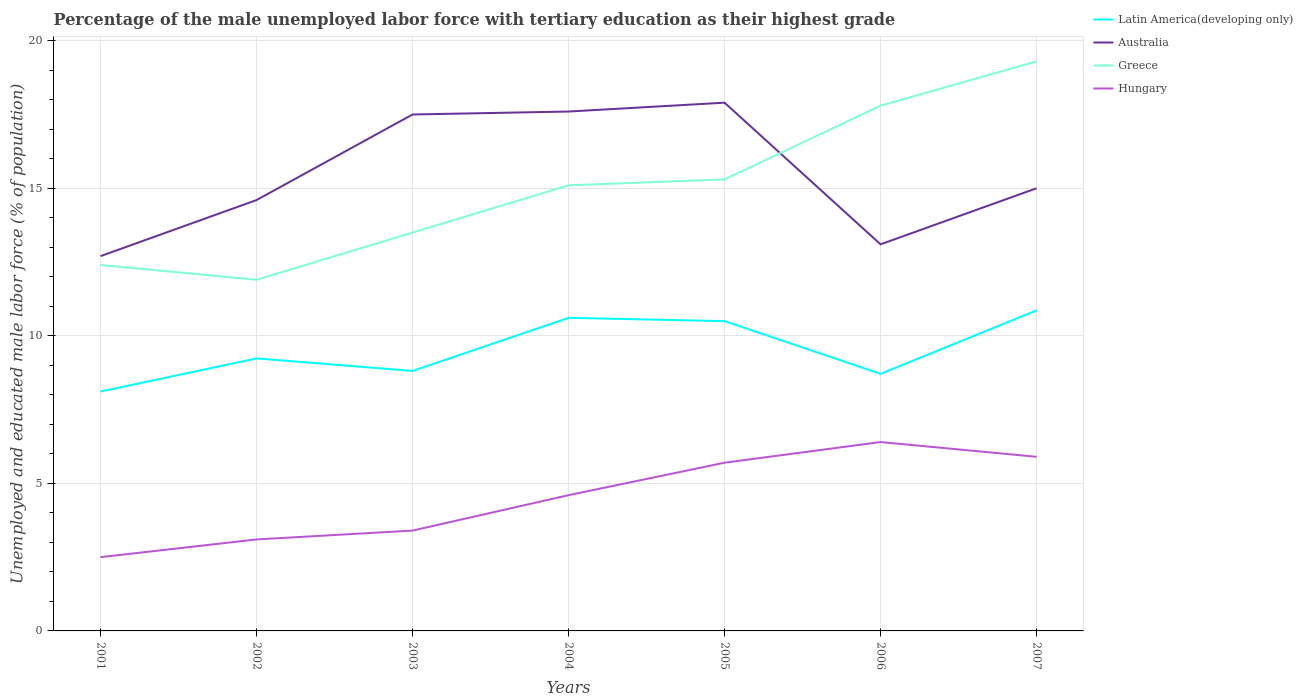How many different coloured lines are there?
Make the answer very short. 4. Does the line corresponding to Australia intersect with the line corresponding to Greece?
Your answer should be very brief. Yes. Is the number of lines equal to the number of legend labels?
Your response must be concise. Yes. Across all years, what is the maximum percentage of the unemployed male labor force with tertiary education in Latin America(developing only)?
Make the answer very short. 8.11. What is the total percentage of the unemployed male labor force with tertiary education in Hungary in the graph?
Provide a succinct answer. -1.2. What is the difference between the highest and the second highest percentage of the unemployed male labor force with tertiary education in Greece?
Keep it short and to the point. 7.4. Is the percentage of the unemployed male labor force with tertiary education in Latin America(developing only) strictly greater than the percentage of the unemployed male labor force with tertiary education in Australia over the years?
Your response must be concise. Yes. How many lines are there?
Your answer should be very brief. 4. Are the values on the major ticks of Y-axis written in scientific E-notation?
Keep it short and to the point. No. Does the graph contain any zero values?
Make the answer very short. No. Does the graph contain grids?
Provide a short and direct response. Yes. Where does the legend appear in the graph?
Your answer should be compact. Top right. What is the title of the graph?
Provide a short and direct response. Percentage of the male unemployed labor force with tertiary education as their highest grade. Does "Burundi" appear as one of the legend labels in the graph?
Make the answer very short. No. What is the label or title of the X-axis?
Provide a short and direct response. Years. What is the label or title of the Y-axis?
Provide a short and direct response. Unemployed and educated male labor force (% of population). What is the Unemployed and educated male labor force (% of population) in Latin America(developing only) in 2001?
Your answer should be compact. 8.11. What is the Unemployed and educated male labor force (% of population) of Australia in 2001?
Make the answer very short. 12.7. What is the Unemployed and educated male labor force (% of population) of Greece in 2001?
Provide a short and direct response. 12.4. What is the Unemployed and educated male labor force (% of population) of Latin America(developing only) in 2002?
Your answer should be very brief. 9.23. What is the Unemployed and educated male labor force (% of population) in Australia in 2002?
Offer a terse response. 14.6. What is the Unemployed and educated male labor force (% of population) in Greece in 2002?
Make the answer very short. 11.9. What is the Unemployed and educated male labor force (% of population) in Hungary in 2002?
Make the answer very short. 3.1. What is the Unemployed and educated male labor force (% of population) in Latin America(developing only) in 2003?
Your answer should be very brief. 8.81. What is the Unemployed and educated male labor force (% of population) in Hungary in 2003?
Provide a succinct answer. 3.4. What is the Unemployed and educated male labor force (% of population) of Latin America(developing only) in 2004?
Your answer should be compact. 10.61. What is the Unemployed and educated male labor force (% of population) of Australia in 2004?
Keep it short and to the point. 17.6. What is the Unemployed and educated male labor force (% of population) in Greece in 2004?
Ensure brevity in your answer.  15.1. What is the Unemployed and educated male labor force (% of population) in Hungary in 2004?
Ensure brevity in your answer.  4.6. What is the Unemployed and educated male labor force (% of population) of Latin America(developing only) in 2005?
Provide a short and direct response. 10.5. What is the Unemployed and educated male labor force (% of population) of Australia in 2005?
Provide a succinct answer. 17.9. What is the Unemployed and educated male labor force (% of population) of Greece in 2005?
Give a very brief answer. 15.3. What is the Unemployed and educated male labor force (% of population) in Hungary in 2005?
Your answer should be compact. 5.7. What is the Unemployed and educated male labor force (% of population) of Latin America(developing only) in 2006?
Your response must be concise. 8.71. What is the Unemployed and educated male labor force (% of population) in Australia in 2006?
Offer a terse response. 13.1. What is the Unemployed and educated male labor force (% of population) in Greece in 2006?
Your answer should be very brief. 17.8. What is the Unemployed and educated male labor force (% of population) in Hungary in 2006?
Offer a very short reply. 6.4. What is the Unemployed and educated male labor force (% of population) in Latin America(developing only) in 2007?
Give a very brief answer. 10.86. What is the Unemployed and educated male labor force (% of population) of Australia in 2007?
Ensure brevity in your answer.  15. What is the Unemployed and educated male labor force (% of population) in Greece in 2007?
Provide a short and direct response. 19.3. What is the Unemployed and educated male labor force (% of population) of Hungary in 2007?
Your response must be concise. 5.9. Across all years, what is the maximum Unemployed and educated male labor force (% of population) of Latin America(developing only)?
Your answer should be compact. 10.86. Across all years, what is the maximum Unemployed and educated male labor force (% of population) of Australia?
Make the answer very short. 17.9. Across all years, what is the maximum Unemployed and educated male labor force (% of population) of Greece?
Your response must be concise. 19.3. Across all years, what is the maximum Unemployed and educated male labor force (% of population) of Hungary?
Provide a short and direct response. 6.4. Across all years, what is the minimum Unemployed and educated male labor force (% of population) of Latin America(developing only)?
Your response must be concise. 8.11. Across all years, what is the minimum Unemployed and educated male labor force (% of population) of Australia?
Your answer should be compact. 12.7. Across all years, what is the minimum Unemployed and educated male labor force (% of population) in Greece?
Offer a very short reply. 11.9. Across all years, what is the minimum Unemployed and educated male labor force (% of population) in Hungary?
Make the answer very short. 2.5. What is the total Unemployed and educated male labor force (% of population) in Latin America(developing only) in the graph?
Provide a short and direct response. 66.84. What is the total Unemployed and educated male labor force (% of population) of Australia in the graph?
Provide a short and direct response. 108.4. What is the total Unemployed and educated male labor force (% of population) of Greece in the graph?
Give a very brief answer. 105.3. What is the total Unemployed and educated male labor force (% of population) of Hungary in the graph?
Provide a succinct answer. 31.6. What is the difference between the Unemployed and educated male labor force (% of population) of Latin America(developing only) in 2001 and that in 2002?
Provide a short and direct response. -1.12. What is the difference between the Unemployed and educated male labor force (% of population) in Australia in 2001 and that in 2002?
Offer a terse response. -1.9. What is the difference between the Unemployed and educated male labor force (% of population) of Greece in 2001 and that in 2002?
Your response must be concise. 0.5. What is the difference between the Unemployed and educated male labor force (% of population) in Latin America(developing only) in 2001 and that in 2003?
Give a very brief answer. -0.7. What is the difference between the Unemployed and educated male labor force (% of population) in Australia in 2001 and that in 2003?
Your response must be concise. -4.8. What is the difference between the Unemployed and educated male labor force (% of population) in Hungary in 2001 and that in 2003?
Provide a succinct answer. -0.9. What is the difference between the Unemployed and educated male labor force (% of population) in Latin America(developing only) in 2001 and that in 2004?
Give a very brief answer. -2.5. What is the difference between the Unemployed and educated male labor force (% of population) in Australia in 2001 and that in 2004?
Offer a very short reply. -4.9. What is the difference between the Unemployed and educated male labor force (% of population) of Hungary in 2001 and that in 2004?
Keep it short and to the point. -2.1. What is the difference between the Unemployed and educated male labor force (% of population) of Latin America(developing only) in 2001 and that in 2005?
Your answer should be very brief. -2.38. What is the difference between the Unemployed and educated male labor force (% of population) of Australia in 2001 and that in 2005?
Provide a short and direct response. -5.2. What is the difference between the Unemployed and educated male labor force (% of population) in Greece in 2001 and that in 2005?
Ensure brevity in your answer.  -2.9. What is the difference between the Unemployed and educated male labor force (% of population) of Hungary in 2001 and that in 2005?
Ensure brevity in your answer.  -3.2. What is the difference between the Unemployed and educated male labor force (% of population) of Latin America(developing only) in 2001 and that in 2006?
Provide a succinct answer. -0.6. What is the difference between the Unemployed and educated male labor force (% of population) in Latin America(developing only) in 2001 and that in 2007?
Your answer should be compact. -2.75. What is the difference between the Unemployed and educated male labor force (% of population) of Greece in 2001 and that in 2007?
Offer a very short reply. -6.9. What is the difference between the Unemployed and educated male labor force (% of population) of Latin America(developing only) in 2002 and that in 2003?
Offer a terse response. 0.43. What is the difference between the Unemployed and educated male labor force (% of population) of Greece in 2002 and that in 2003?
Your response must be concise. -1.6. What is the difference between the Unemployed and educated male labor force (% of population) in Hungary in 2002 and that in 2003?
Keep it short and to the point. -0.3. What is the difference between the Unemployed and educated male labor force (% of population) in Latin America(developing only) in 2002 and that in 2004?
Provide a short and direct response. -1.37. What is the difference between the Unemployed and educated male labor force (% of population) of Latin America(developing only) in 2002 and that in 2005?
Ensure brevity in your answer.  -1.26. What is the difference between the Unemployed and educated male labor force (% of population) of Australia in 2002 and that in 2005?
Give a very brief answer. -3.3. What is the difference between the Unemployed and educated male labor force (% of population) in Latin America(developing only) in 2002 and that in 2006?
Your answer should be compact. 0.52. What is the difference between the Unemployed and educated male labor force (% of population) in Latin America(developing only) in 2002 and that in 2007?
Make the answer very short. -1.63. What is the difference between the Unemployed and educated male labor force (% of population) of Greece in 2002 and that in 2007?
Your response must be concise. -7.4. What is the difference between the Unemployed and educated male labor force (% of population) of Hungary in 2002 and that in 2007?
Make the answer very short. -2.8. What is the difference between the Unemployed and educated male labor force (% of population) in Latin America(developing only) in 2003 and that in 2004?
Your response must be concise. -1.8. What is the difference between the Unemployed and educated male labor force (% of population) of Australia in 2003 and that in 2004?
Ensure brevity in your answer.  -0.1. What is the difference between the Unemployed and educated male labor force (% of population) in Greece in 2003 and that in 2004?
Keep it short and to the point. -1.6. What is the difference between the Unemployed and educated male labor force (% of population) in Hungary in 2003 and that in 2004?
Your answer should be compact. -1.2. What is the difference between the Unemployed and educated male labor force (% of population) in Latin America(developing only) in 2003 and that in 2005?
Ensure brevity in your answer.  -1.69. What is the difference between the Unemployed and educated male labor force (% of population) of Greece in 2003 and that in 2005?
Your answer should be compact. -1.8. What is the difference between the Unemployed and educated male labor force (% of population) in Hungary in 2003 and that in 2005?
Give a very brief answer. -2.3. What is the difference between the Unemployed and educated male labor force (% of population) in Latin America(developing only) in 2003 and that in 2006?
Your answer should be compact. 0.1. What is the difference between the Unemployed and educated male labor force (% of population) of Greece in 2003 and that in 2006?
Your answer should be compact. -4.3. What is the difference between the Unemployed and educated male labor force (% of population) of Latin America(developing only) in 2003 and that in 2007?
Provide a short and direct response. -2.05. What is the difference between the Unemployed and educated male labor force (% of population) in Australia in 2003 and that in 2007?
Make the answer very short. 2.5. What is the difference between the Unemployed and educated male labor force (% of population) of Greece in 2003 and that in 2007?
Your response must be concise. -5.8. What is the difference between the Unemployed and educated male labor force (% of population) of Hungary in 2003 and that in 2007?
Give a very brief answer. -2.5. What is the difference between the Unemployed and educated male labor force (% of population) in Latin America(developing only) in 2004 and that in 2005?
Your response must be concise. 0.11. What is the difference between the Unemployed and educated male labor force (% of population) of Australia in 2004 and that in 2005?
Your answer should be compact. -0.3. What is the difference between the Unemployed and educated male labor force (% of population) in Hungary in 2004 and that in 2005?
Provide a short and direct response. -1.1. What is the difference between the Unemployed and educated male labor force (% of population) in Latin America(developing only) in 2004 and that in 2006?
Provide a short and direct response. 1.9. What is the difference between the Unemployed and educated male labor force (% of population) in Australia in 2004 and that in 2006?
Your answer should be compact. 4.5. What is the difference between the Unemployed and educated male labor force (% of population) of Latin America(developing only) in 2004 and that in 2007?
Your response must be concise. -0.25. What is the difference between the Unemployed and educated male labor force (% of population) in Australia in 2004 and that in 2007?
Give a very brief answer. 2.6. What is the difference between the Unemployed and educated male labor force (% of population) in Greece in 2004 and that in 2007?
Your answer should be compact. -4.2. What is the difference between the Unemployed and educated male labor force (% of population) of Hungary in 2004 and that in 2007?
Offer a very short reply. -1.3. What is the difference between the Unemployed and educated male labor force (% of population) in Latin America(developing only) in 2005 and that in 2006?
Make the answer very short. 1.79. What is the difference between the Unemployed and educated male labor force (% of population) in Greece in 2005 and that in 2006?
Provide a short and direct response. -2.5. What is the difference between the Unemployed and educated male labor force (% of population) of Hungary in 2005 and that in 2006?
Ensure brevity in your answer.  -0.7. What is the difference between the Unemployed and educated male labor force (% of population) in Latin America(developing only) in 2005 and that in 2007?
Provide a succinct answer. -0.37. What is the difference between the Unemployed and educated male labor force (% of population) of Latin America(developing only) in 2006 and that in 2007?
Provide a succinct answer. -2.15. What is the difference between the Unemployed and educated male labor force (% of population) in Greece in 2006 and that in 2007?
Keep it short and to the point. -1.5. What is the difference between the Unemployed and educated male labor force (% of population) in Latin America(developing only) in 2001 and the Unemployed and educated male labor force (% of population) in Australia in 2002?
Offer a very short reply. -6.49. What is the difference between the Unemployed and educated male labor force (% of population) in Latin America(developing only) in 2001 and the Unemployed and educated male labor force (% of population) in Greece in 2002?
Keep it short and to the point. -3.79. What is the difference between the Unemployed and educated male labor force (% of population) in Latin America(developing only) in 2001 and the Unemployed and educated male labor force (% of population) in Hungary in 2002?
Provide a succinct answer. 5.01. What is the difference between the Unemployed and educated male labor force (% of population) of Australia in 2001 and the Unemployed and educated male labor force (% of population) of Greece in 2002?
Offer a terse response. 0.8. What is the difference between the Unemployed and educated male labor force (% of population) of Australia in 2001 and the Unemployed and educated male labor force (% of population) of Hungary in 2002?
Provide a short and direct response. 9.6. What is the difference between the Unemployed and educated male labor force (% of population) in Greece in 2001 and the Unemployed and educated male labor force (% of population) in Hungary in 2002?
Keep it short and to the point. 9.3. What is the difference between the Unemployed and educated male labor force (% of population) of Latin America(developing only) in 2001 and the Unemployed and educated male labor force (% of population) of Australia in 2003?
Ensure brevity in your answer.  -9.39. What is the difference between the Unemployed and educated male labor force (% of population) of Latin America(developing only) in 2001 and the Unemployed and educated male labor force (% of population) of Greece in 2003?
Offer a terse response. -5.39. What is the difference between the Unemployed and educated male labor force (% of population) in Latin America(developing only) in 2001 and the Unemployed and educated male labor force (% of population) in Hungary in 2003?
Ensure brevity in your answer.  4.71. What is the difference between the Unemployed and educated male labor force (% of population) in Greece in 2001 and the Unemployed and educated male labor force (% of population) in Hungary in 2003?
Offer a terse response. 9. What is the difference between the Unemployed and educated male labor force (% of population) of Latin America(developing only) in 2001 and the Unemployed and educated male labor force (% of population) of Australia in 2004?
Provide a short and direct response. -9.49. What is the difference between the Unemployed and educated male labor force (% of population) of Latin America(developing only) in 2001 and the Unemployed and educated male labor force (% of population) of Greece in 2004?
Provide a succinct answer. -6.99. What is the difference between the Unemployed and educated male labor force (% of population) of Latin America(developing only) in 2001 and the Unemployed and educated male labor force (% of population) of Hungary in 2004?
Offer a terse response. 3.51. What is the difference between the Unemployed and educated male labor force (% of population) in Australia in 2001 and the Unemployed and educated male labor force (% of population) in Greece in 2004?
Your response must be concise. -2.4. What is the difference between the Unemployed and educated male labor force (% of population) of Greece in 2001 and the Unemployed and educated male labor force (% of population) of Hungary in 2004?
Keep it short and to the point. 7.8. What is the difference between the Unemployed and educated male labor force (% of population) in Latin America(developing only) in 2001 and the Unemployed and educated male labor force (% of population) in Australia in 2005?
Provide a short and direct response. -9.79. What is the difference between the Unemployed and educated male labor force (% of population) of Latin America(developing only) in 2001 and the Unemployed and educated male labor force (% of population) of Greece in 2005?
Your answer should be compact. -7.19. What is the difference between the Unemployed and educated male labor force (% of population) in Latin America(developing only) in 2001 and the Unemployed and educated male labor force (% of population) in Hungary in 2005?
Offer a very short reply. 2.41. What is the difference between the Unemployed and educated male labor force (% of population) of Australia in 2001 and the Unemployed and educated male labor force (% of population) of Greece in 2005?
Make the answer very short. -2.6. What is the difference between the Unemployed and educated male labor force (% of population) of Greece in 2001 and the Unemployed and educated male labor force (% of population) of Hungary in 2005?
Ensure brevity in your answer.  6.7. What is the difference between the Unemployed and educated male labor force (% of population) in Latin America(developing only) in 2001 and the Unemployed and educated male labor force (% of population) in Australia in 2006?
Provide a succinct answer. -4.99. What is the difference between the Unemployed and educated male labor force (% of population) of Latin America(developing only) in 2001 and the Unemployed and educated male labor force (% of population) of Greece in 2006?
Provide a short and direct response. -9.69. What is the difference between the Unemployed and educated male labor force (% of population) of Latin America(developing only) in 2001 and the Unemployed and educated male labor force (% of population) of Hungary in 2006?
Provide a succinct answer. 1.71. What is the difference between the Unemployed and educated male labor force (% of population) in Australia in 2001 and the Unemployed and educated male labor force (% of population) in Greece in 2006?
Your answer should be very brief. -5.1. What is the difference between the Unemployed and educated male labor force (% of population) in Latin America(developing only) in 2001 and the Unemployed and educated male labor force (% of population) in Australia in 2007?
Provide a succinct answer. -6.89. What is the difference between the Unemployed and educated male labor force (% of population) in Latin America(developing only) in 2001 and the Unemployed and educated male labor force (% of population) in Greece in 2007?
Keep it short and to the point. -11.19. What is the difference between the Unemployed and educated male labor force (% of population) of Latin America(developing only) in 2001 and the Unemployed and educated male labor force (% of population) of Hungary in 2007?
Offer a very short reply. 2.21. What is the difference between the Unemployed and educated male labor force (% of population) in Australia in 2001 and the Unemployed and educated male labor force (% of population) in Hungary in 2007?
Give a very brief answer. 6.8. What is the difference between the Unemployed and educated male labor force (% of population) in Greece in 2001 and the Unemployed and educated male labor force (% of population) in Hungary in 2007?
Your answer should be very brief. 6.5. What is the difference between the Unemployed and educated male labor force (% of population) of Latin America(developing only) in 2002 and the Unemployed and educated male labor force (% of population) of Australia in 2003?
Provide a succinct answer. -8.27. What is the difference between the Unemployed and educated male labor force (% of population) in Latin America(developing only) in 2002 and the Unemployed and educated male labor force (% of population) in Greece in 2003?
Keep it short and to the point. -4.27. What is the difference between the Unemployed and educated male labor force (% of population) in Latin America(developing only) in 2002 and the Unemployed and educated male labor force (% of population) in Hungary in 2003?
Your answer should be very brief. 5.83. What is the difference between the Unemployed and educated male labor force (% of population) in Australia in 2002 and the Unemployed and educated male labor force (% of population) in Greece in 2003?
Keep it short and to the point. 1.1. What is the difference between the Unemployed and educated male labor force (% of population) in Australia in 2002 and the Unemployed and educated male labor force (% of population) in Hungary in 2003?
Make the answer very short. 11.2. What is the difference between the Unemployed and educated male labor force (% of population) in Latin America(developing only) in 2002 and the Unemployed and educated male labor force (% of population) in Australia in 2004?
Make the answer very short. -8.37. What is the difference between the Unemployed and educated male labor force (% of population) of Latin America(developing only) in 2002 and the Unemployed and educated male labor force (% of population) of Greece in 2004?
Offer a terse response. -5.87. What is the difference between the Unemployed and educated male labor force (% of population) in Latin America(developing only) in 2002 and the Unemployed and educated male labor force (% of population) in Hungary in 2004?
Offer a very short reply. 4.63. What is the difference between the Unemployed and educated male labor force (% of population) in Australia in 2002 and the Unemployed and educated male labor force (% of population) in Greece in 2004?
Offer a very short reply. -0.5. What is the difference between the Unemployed and educated male labor force (% of population) of Australia in 2002 and the Unemployed and educated male labor force (% of population) of Hungary in 2004?
Make the answer very short. 10. What is the difference between the Unemployed and educated male labor force (% of population) of Greece in 2002 and the Unemployed and educated male labor force (% of population) of Hungary in 2004?
Make the answer very short. 7.3. What is the difference between the Unemployed and educated male labor force (% of population) of Latin America(developing only) in 2002 and the Unemployed and educated male labor force (% of population) of Australia in 2005?
Ensure brevity in your answer.  -8.67. What is the difference between the Unemployed and educated male labor force (% of population) in Latin America(developing only) in 2002 and the Unemployed and educated male labor force (% of population) in Greece in 2005?
Offer a very short reply. -6.07. What is the difference between the Unemployed and educated male labor force (% of population) in Latin America(developing only) in 2002 and the Unemployed and educated male labor force (% of population) in Hungary in 2005?
Keep it short and to the point. 3.53. What is the difference between the Unemployed and educated male labor force (% of population) in Latin America(developing only) in 2002 and the Unemployed and educated male labor force (% of population) in Australia in 2006?
Your answer should be compact. -3.87. What is the difference between the Unemployed and educated male labor force (% of population) in Latin America(developing only) in 2002 and the Unemployed and educated male labor force (% of population) in Greece in 2006?
Keep it short and to the point. -8.57. What is the difference between the Unemployed and educated male labor force (% of population) in Latin America(developing only) in 2002 and the Unemployed and educated male labor force (% of population) in Hungary in 2006?
Ensure brevity in your answer.  2.83. What is the difference between the Unemployed and educated male labor force (% of population) of Greece in 2002 and the Unemployed and educated male labor force (% of population) of Hungary in 2006?
Keep it short and to the point. 5.5. What is the difference between the Unemployed and educated male labor force (% of population) in Latin America(developing only) in 2002 and the Unemployed and educated male labor force (% of population) in Australia in 2007?
Provide a succinct answer. -5.77. What is the difference between the Unemployed and educated male labor force (% of population) of Latin America(developing only) in 2002 and the Unemployed and educated male labor force (% of population) of Greece in 2007?
Make the answer very short. -10.07. What is the difference between the Unemployed and educated male labor force (% of population) of Latin America(developing only) in 2002 and the Unemployed and educated male labor force (% of population) of Hungary in 2007?
Give a very brief answer. 3.33. What is the difference between the Unemployed and educated male labor force (% of population) of Australia in 2002 and the Unemployed and educated male labor force (% of population) of Greece in 2007?
Make the answer very short. -4.7. What is the difference between the Unemployed and educated male labor force (% of population) of Australia in 2002 and the Unemployed and educated male labor force (% of population) of Hungary in 2007?
Provide a short and direct response. 8.7. What is the difference between the Unemployed and educated male labor force (% of population) of Latin America(developing only) in 2003 and the Unemployed and educated male labor force (% of population) of Australia in 2004?
Keep it short and to the point. -8.79. What is the difference between the Unemployed and educated male labor force (% of population) in Latin America(developing only) in 2003 and the Unemployed and educated male labor force (% of population) in Greece in 2004?
Ensure brevity in your answer.  -6.29. What is the difference between the Unemployed and educated male labor force (% of population) in Latin America(developing only) in 2003 and the Unemployed and educated male labor force (% of population) in Hungary in 2004?
Give a very brief answer. 4.21. What is the difference between the Unemployed and educated male labor force (% of population) of Australia in 2003 and the Unemployed and educated male labor force (% of population) of Greece in 2004?
Your answer should be compact. 2.4. What is the difference between the Unemployed and educated male labor force (% of population) in Greece in 2003 and the Unemployed and educated male labor force (% of population) in Hungary in 2004?
Give a very brief answer. 8.9. What is the difference between the Unemployed and educated male labor force (% of population) of Latin America(developing only) in 2003 and the Unemployed and educated male labor force (% of population) of Australia in 2005?
Give a very brief answer. -9.09. What is the difference between the Unemployed and educated male labor force (% of population) of Latin America(developing only) in 2003 and the Unemployed and educated male labor force (% of population) of Greece in 2005?
Ensure brevity in your answer.  -6.49. What is the difference between the Unemployed and educated male labor force (% of population) in Latin America(developing only) in 2003 and the Unemployed and educated male labor force (% of population) in Hungary in 2005?
Provide a succinct answer. 3.11. What is the difference between the Unemployed and educated male labor force (% of population) of Australia in 2003 and the Unemployed and educated male labor force (% of population) of Greece in 2005?
Provide a succinct answer. 2.2. What is the difference between the Unemployed and educated male labor force (% of population) of Australia in 2003 and the Unemployed and educated male labor force (% of population) of Hungary in 2005?
Your answer should be very brief. 11.8. What is the difference between the Unemployed and educated male labor force (% of population) in Greece in 2003 and the Unemployed and educated male labor force (% of population) in Hungary in 2005?
Provide a succinct answer. 7.8. What is the difference between the Unemployed and educated male labor force (% of population) in Latin America(developing only) in 2003 and the Unemployed and educated male labor force (% of population) in Australia in 2006?
Provide a short and direct response. -4.29. What is the difference between the Unemployed and educated male labor force (% of population) of Latin America(developing only) in 2003 and the Unemployed and educated male labor force (% of population) of Greece in 2006?
Give a very brief answer. -8.99. What is the difference between the Unemployed and educated male labor force (% of population) of Latin America(developing only) in 2003 and the Unemployed and educated male labor force (% of population) of Hungary in 2006?
Your answer should be very brief. 2.41. What is the difference between the Unemployed and educated male labor force (% of population) of Australia in 2003 and the Unemployed and educated male labor force (% of population) of Hungary in 2006?
Your answer should be compact. 11.1. What is the difference between the Unemployed and educated male labor force (% of population) in Greece in 2003 and the Unemployed and educated male labor force (% of population) in Hungary in 2006?
Ensure brevity in your answer.  7.1. What is the difference between the Unemployed and educated male labor force (% of population) of Latin America(developing only) in 2003 and the Unemployed and educated male labor force (% of population) of Australia in 2007?
Offer a terse response. -6.19. What is the difference between the Unemployed and educated male labor force (% of population) of Latin America(developing only) in 2003 and the Unemployed and educated male labor force (% of population) of Greece in 2007?
Your response must be concise. -10.49. What is the difference between the Unemployed and educated male labor force (% of population) in Latin America(developing only) in 2003 and the Unemployed and educated male labor force (% of population) in Hungary in 2007?
Your answer should be compact. 2.91. What is the difference between the Unemployed and educated male labor force (% of population) of Australia in 2003 and the Unemployed and educated male labor force (% of population) of Greece in 2007?
Give a very brief answer. -1.8. What is the difference between the Unemployed and educated male labor force (% of population) of Australia in 2003 and the Unemployed and educated male labor force (% of population) of Hungary in 2007?
Offer a terse response. 11.6. What is the difference between the Unemployed and educated male labor force (% of population) in Latin America(developing only) in 2004 and the Unemployed and educated male labor force (% of population) in Australia in 2005?
Provide a short and direct response. -7.29. What is the difference between the Unemployed and educated male labor force (% of population) of Latin America(developing only) in 2004 and the Unemployed and educated male labor force (% of population) of Greece in 2005?
Your answer should be very brief. -4.69. What is the difference between the Unemployed and educated male labor force (% of population) of Latin America(developing only) in 2004 and the Unemployed and educated male labor force (% of population) of Hungary in 2005?
Make the answer very short. 4.91. What is the difference between the Unemployed and educated male labor force (% of population) in Latin America(developing only) in 2004 and the Unemployed and educated male labor force (% of population) in Australia in 2006?
Provide a short and direct response. -2.49. What is the difference between the Unemployed and educated male labor force (% of population) in Latin America(developing only) in 2004 and the Unemployed and educated male labor force (% of population) in Greece in 2006?
Ensure brevity in your answer.  -7.19. What is the difference between the Unemployed and educated male labor force (% of population) in Latin America(developing only) in 2004 and the Unemployed and educated male labor force (% of population) in Hungary in 2006?
Your response must be concise. 4.21. What is the difference between the Unemployed and educated male labor force (% of population) of Australia in 2004 and the Unemployed and educated male labor force (% of population) of Greece in 2006?
Offer a terse response. -0.2. What is the difference between the Unemployed and educated male labor force (% of population) in Greece in 2004 and the Unemployed and educated male labor force (% of population) in Hungary in 2006?
Provide a succinct answer. 8.7. What is the difference between the Unemployed and educated male labor force (% of population) in Latin America(developing only) in 2004 and the Unemployed and educated male labor force (% of population) in Australia in 2007?
Ensure brevity in your answer.  -4.39. What is the difference between the Unemployed and educated male labor force (% of population) of Latin America(developing only) in 2004 and the Unemployed and educated male labor force (% of population) of Greece in 2007?
Provide a succinct answer. -8.69. What is the difference between the Unemployed and educated male labor force (% of population) in Latin America(developing only) in 2004 and the Unemployed and educated male labor force (% of population) in Hungary in 2007?
Provide a short and direct response. 4.71. What is the difference between the Unemployed and educated male labor force (% of population) in Australia in 2004 and the Unemployed and educated male labor force (% of population) in Greece in 2007?
Ensure brevity in your answer.  -1.7. What is the difference between the Unemployed and educated male labor force (% of population) in Australia in 2004 and the Unemployed and educated male labor force (% of population) in Hungary in 2007?
Provide a succinct answer. 11.7. What is the difference between the Unemployed and educated male labor force (% of population) of Latin America(developing only) in 2005 and the Unemployed and educated male labor force (% of population) of Australia in 2006?
Give a very brief answer. -2.6. What is the difference between the Unemployed and educated male labor force (% of population) in Latin America(developing only) in 2005 and the Unemployed and educated male labor force (% of population) in Greece in 2006?
Offer a very short reply. -7.3. What is the difference between the Unemployed and educated male labor force (% of population) in Latin America(developing only) in 2005 and the Unemployed and educated male labor force (% of population) in Hungary in 2006?
Offer a very short reply. 4.1. What is the difference between the Unemployed and educated male labor force (% of population) in Australia in 2005 and the Unemployed and educated male labor force (% of population) in Greece in 2006?
Provide a short and direct response. 0.1. What is the difference between the Unemployed and educated male labor force (% of population) of Australia in 2005 and the Unemployed and educated male labor force (% of population) of Hungary in 2006?
Provide a succinct answer. 11.5. What is the difference between the Unemployed and educated male labor force (% of population) of Greece in 2005 and the Unemployed and educated male labor force (% of population) of Hungary in 2006?
Make the answer very short. 8.9. What is the difference between the Unemployed and educated male labor force (% of population) of Latin America(developing only) in 2005 and the Unemployed and educated male labor force (% of population) of Australia in 2007?
Offer a very short reply. -4.5. What is the difference between the Unemployed and educated male labor force (% of population) in Latin America(developing only) in 2005 and the Unemployed and educated male labor force (% of population) in Greece in 2007?
Keep it short and to the point. -8.8. What is the difference between the Unemployed and educated male labor force (% of population) of Latin America(developing only) in 2005 and the Unemployed and educated male labor force (% of population) of Hungary in 2007?
Keep it short and to the point. 4.6. What is the difference between the Unemployed and educated male labor force (% of population) in Australia in 2005 and the Unemployed and educated male labor force (% of population) in Greece in 2007?
Your response must be concise. -1.4. What is the difference between the Unemployed and educated male labor force (% of population) in Australia in 2005 and the Unemployed and educated male labor force (% of population) in Hungary in 2007?
Provide a succinct answer. 12. What is the difference between the Unemployed and educated male labor force (% of population) in Latin America(developing only) in 2006 and the Unemployed and educated male labor force (% of population) in Australia in 2007?
Keep it short and to the point. -6.29. What is the difference between the Unemployed and educated male labor force (% of population) of Latin America(developing only) in 2006 and the Unemployed and educated male labor force (% of population) of Greece in 2007?
Offer a very short reply. -10.59. What is the difference between the Unemployed and educated male labor force (% of population) of Latin America(developing only) in 2006 and the Unemployed and educated male labor force (% of population) of Hungary in 2007?
Your answer should be compact. 2.81. What is the difference between the Unemployed and educated male labor force (% of population) of Australia in 2006 and the Unemployed and educated male labor force (% of population) of Greece in 2007?
Give a very brief answer. -6.2. What is the difference between the Unemployed and educated male labor force (% of population) in Greece in 2006 and the Unemployed and educated male labor force (% of population) in Hungary in 2007?
Keep it short and to the point. 11.9. What is the average Unemployed and educated male labor force (% of population) in Latin America(developing only) per year?
Offer a very short reply. 9.55. What is the average Unemployed and educated male labor force (% of population) of Australia per year?
Your answer should be very brief. 15.49. What is the average Unemployed and educated male labor force (% of population) of Greece per year?
Your response must be concise. 15.04. What is the average Unemployed and educated male labor force (% of population) in Hungary per year?
Make the answer very short. 4.51. In the year 2001, what is the difference between the Unemployed and educated male labor force (% of population) of Latin America(developing only) and Unemployed and educated male labor force (% of population) of Australia?
Provide a succinct answer. -4.59. In the year 2001, what is the difference between the Unemployed and educated male labor force (% of population) in Latin America(developing only) and Unemployed and educated male labor force (% of population) in Greece?
Ensure brevity in your answer.  -4.29. In the year 2001, what is the difference between the Unemployed and educated male labor force (% of population) in Latin America(developing only) and Unemployed and educated male labor force (% of population) in Hungary?
Offer a terse response. 5.61. In the year 2001, what is the difference between the Unemployed and educated male labor force (% of population) in Australia and Unemployed and educated male labor force (% of population) in Greece?
Provide a succinct answer. 0.3. In the year 2002, what is the difference between the Unemployed and educated male labor force (% of population) in Latin America(developing only) and Unemployed and educated male labor force (% of population) in Australia?
Offer a terse response. -5.37. In the year 2002, what is the difference between the Unemployed and educated male labor force (% of population) of Latin America(developing only) and Unemployed and educated male labor force (% of population) of Greece?
Keep it short and to the point. -2.67. In the year 2002, what is the difference between the Unemployed and educated male labor force (% of population) of Latin America(developing only) and Unemployed and educated male labor force (% of population) of Hungary?
Provide a short and direct response. 6.13. In the year 2002, what is the difference between the Unemployed and educated male labor force (% of population) of Australia and Unemployed and educated male labor force (% of population) of Hungary?
Give a very brief answer. 11.5. In the year 2002, what is the difference between the Unemployed and educated male labor force (% of population) of Greece and Unemployed and educated male labor force (% of population) of Hungary?
Keep it short and to the point. 8.8. In the year 2003, what is the difference between the Unemployed and educated male labor force (% of population) in Latin America(developing only) and Unemployed and educated male labor force (% of population) in Australia?
Your answer should be very brief. -8.69. In the year 2003, what is the difference between the Unemployed and educated male labor force (% of population) in Latin America(developing only) and Unemployed and educated male labor force (% of population) in Greece?
Provide a succinct answer. -4.69. In the year 2003, what is the difference between the Unemployed and educated male labor force (% of population) in Latin America(developing only) and Unemployed and educated male labor force (% of population) in Hungary?
Give a very brief answer. 5.41. In the year 2004, what is the difference between the Unemployed and educated male labor force (% of population) of Latin America(developing only) and Unemployed and educated male labor force (% of population) of Australia?
Offer a very short reply. -6.99. In the year 2004, what is the difference between the Unemployed and educated male labor force (% of population) in Latin America(developing only) and Unemployed and educated male labor force (% of population) in Greece?
Offer a very short reply. -4.49. In the year 2004, what is the difference between the Unemployed and educated male labor force (% of population) in Latin America(developing only) and Unemployed and educated male labor force (% of population) in Hungary?
Provide a short and direct response. 6.01. In the year 2004, what is the difference between the Unemployed and educated male labor force (% of population) in Greece and Unemployed and educated male labor force (% of population) in Hungary?
Keep it short and to the point. 10.5. In the year 2005, what is the difference between the Unemployed and educated male labor force (% of population) in Latin America(developing only) and Unemployed and educated male labor force (% of population) in Australia?
Give a very brief answer. -7.4. In the year 2005, what is the difference between the Unemployed and educated male labor force (% of population) of Latin America(developing only) and Unemployed and educated male labor force (% of population) of Greece?
Provide a short and direct response. -4.8. In the year 2005, what is the difference between the Unemployed and educated male labor force (% of population) in Latin America(developing only) and Unemployed and educated male labor force (% of population) in Hungary?
Your answer should be very brief. 4.8. In the year 2005, what is the difference between the Unemployed and educated male labor force (% of population) of Australia and Unemployed and educated male labor force (% of population) of Greece?
Provide a short and direct response. 2.6. In the year 2005, what is the difference between the Unemployed and educated male labor force (% of population) in Greece and Unemployed and educated male labor force (% of population) in Hungary?
Your answer should be very brief. 9.6. In the year 2006, what is the difference between the Unemployed and educated male labor force (% of population) in Latin America(developing only) and Unemployed and educated male labor force (% of population) in Australia?
Offer a very short reply. -4.39. In the year 2006, what is the difference between the Unemployed and educated male labor force (% of population) in Latin America(developing only) and Unemployed and educated male labor force (% of population) in Greece?
Keep it short and to the point. -9.09. In the year 2006, what is the difference between the Unemployed and educated male labor force (% of population) in Latin America(developing only) and Unemployed and educated male labor force (% of population) in Hungary?
Provide a succinct answer. 2.31. In the year 2006, what is the difference between the Unemployed and educated male labor force (% of population) of Australia and Unemployed and educated male labor force (% of population) of Greece?
Ensure brevity in your answer.  -4.7. In the year 2006, what is the difference between the Unemployed and educated male labor force (% of population) of Greece and Unemployed and educated male labor force (% of population) of Hungary?
Ensure brevity in your answer.  11.4. In the year 2007, what is the difference between the Unemployed and educated male labor force (% of population) of Latin America(developing only) and Unemployed and educated male labor force (% of population) of Australia?
Make the answer very short. -4.14. In the year 2007, what is the difference between the Unemployed and educated male labor force (% of population) in Latin America(developing only) and Unemployed and educated male labor force (% of population) in Greece?
Your answer should be compact. -8.44. In the year 2007, what is the difference between the Unemployed and educated male labor force (% of population) of Latin America(developing only) and Unemployed and educated male labor force (% of population) of Hungary?
Ensure brevity in your answer.  4.96. In the year 2007, what is the difference between the Unemployed and educated male labor force (% of population) of Australia and Unemployed and educated male labor force (% of population) of Greece?
Provide a short and direct response. -4.3. In the year 2007, what is the difference between the Unemployed and educated male labor force (% of population) in Greece and Unemployed and educated male labor force (% of population) in Hungary?
Your response must be concise. 13.4. What is the ratio of the Unemployed and educated male labor force (% of population) in Latin America(developing only) in 2001 to that in 2002?
Give a very brief answer. 0.88. What is the ratio of the Unemployed and educated male labor force (% of population) in Australia in 2001 to that in 2002?
Give a very brief answer. 0.87. What is the ratio of the Unemployed and educated male labor force (% of population) in Greece in 2001 to that in 2002?
Provide a succinct answer. 1.04. What is the ratio of the Unemployed and educated male labor force (% of population) of Hungary in 2001 to that in 2002?
Provide a short and direct response. 0.81. What is the ratio of the Unemployed and educated male labor force (% of population) in Latin America(developing only) in 2001 to that in 2003?
Give a very brief answer. 0.92. What is the ratio of the Unemployed and educated male labor force (% of population) of Australia in 2001 to that in 2003?
Keep it short and to the point. 0.73. What is the ratio of the Unemployed and educated male labor force (% of population) of Greece in 2001 to that in 2003?
Your answer should be very brief. 0.92. What is the ratio of the Unemployed and educated male labor force (% of population) in Hungary in 2001 to that in 2003?
Your response must be concise. 0.74. What is the ratio of the Unemployed and educated male labor force (% of population) in Latin America(developing only) in 2001 to that in 2004?
Give a very brief answer. 0.76. What is the ratio of the Unemployed and educated male labor force (% of population) in Australia in 2001 to that in 2004?
Offer a terse response. 0.72. What is the ratio of the Unemployed and educated male labor force (% of population) in Greece in 2001 to that in 2004?
Your answer should be compact. 0.82. What is the ratio of the Unemployed and educated male labor force (% of population) of Hungary in 2001 to that in 2004?
Your answer should be compact. 0.54. What is the ratio of the Unemployed and educated male labor force (% of population) of Latin America(developing only) in 2001 to that in 2005?
Your answer should be very brief. 0.77. What is the ratio of the Unemployed and educated male labor force (% of population) of Australia in 2001 to that in 2005?
Give a very brief answer. 0.71. What is the ratio of the Unemployed and educated male labor force (% of population) in Greece in 2001 to that in 2005?
Provide a short and direct response. 0.81. What is the ratio of the Unemployed and educated male labor force (% of population) of Hungary in 2001 to that in 2005?
Provide a short and direct response. 0.44. What is the ratio of the Unemployed and educated male labor force (% of population) of Latin America(developing only) in 2001 to that in 2006?
Keep it short and to the point. 0.93. What is the ratio of the Unemployed and educated male labor force (% of population) in Australia in 2001 to that in 2006?
Provide a succinct answer. 0.97. What is the ratio of the Unemployed and educated male labor force (% of population) of Greece in 2001 to that in 2006?
Your answer should be compact. 0.7. What is the ratio of the Unemployed and educated male labor force (% of population) of Hungary in 2001 to that in 2006?
Ensure brevity in your answer.  0.39. What is the ratio of the Unemployed and educated male labor force (% of population) of Latin America(developing only) in 2001 to that in 2007?
Offer a terse response. 0.75. What is the ratio of the Unemployed and educated male labor force (% of population) in Australia in 2001 to that in 2007?
Keep it short and to the point. 0.85. What is the ratio of the Unemployed and educated male labor force (% of population) in Greece in 2001 to that in 2007?
Provide a short and direct response. 0.64. What is the ratio of the Unemployed and educated male labor force (% of population) in Hungary in 2001 to that in 2007?
Your response must be concise. 0.42. What is the ratio of the Unemployed and educated male labor force (% of population) in Latin America(developing only) in 2002 to that in 2003?
Provide a succinct answer. 1.05. What is the ratio of the Unemployed and educated male labor force (% of population) in Australia in 2002 to that in 2003?
Keep it short and to the point. 0.83. What is the ratio of the Unemployed and educated male labor force (% of population) of Greece in 2002 to that in 2003?
Your answer should be very brief. 0.88. What is the ratio of the Unemployed and educated male labor force (% of population) of Hungary in 2002 to that in 2003?
Provide a succinct answer. 0.91. What is the ratio of the Unemployed and educated male labor force (% of population) in Latin America(developing only) in 2002 to that in 2004?
Provide a short and direct response. 0.87. What is the ratio of the Unemployed and educated male labor force (% of population) of Australia in 2002 to that in 2004?
Make the answer very short. 0.83. What is the ratio of the Unemployed and educated male labor force (% of population) in Greece in 2002 to that in 2004?
Give a very brief answer. 0.79. What is the ratio of the Unemployed and educated male labor force (% of population) in Hungary in 2002 to that in 2004?
Your answer should be very brief. 0.67. What is the ratio of the Unemployed and educated male labor force (% of population) of Latin America(developing only) in 2002 to that in 2005?
Your answer should be very brief. 0.88. What is the ratio of the Unemployed and educated male labor force (% of population) of Australia in 2002 to that in 2005?
Make the answer very short. 0.82. What is the ratio of the Unemployed and educated male labor force (% of population) in Greece in 2002 to that in 2005?
Your answer should be compact. 0.78. What is the ratio of the Unemployed and educated male labor force (% of population) in Hungary in 2002 to that in 2005?
Provide a succinct answer. 0.54. What is the ratio of the Unemployed and educated male labor force (% of population) of Latin America(developing only) in 2002 to that in 2006?
Provide a succinct answer. 1.06. What is the ratio of the Unemployed and educated male labor force (% of population) in Australia in 2002 to that in 2006?
Your response must be concise. 1.11. What is the ratio of the Unemployed and educated male labor force (% of population) of Greece in 2002 to that in 2006?
Provide a succinct answer. 0.67. What is the ratio of the Unemployed and educated male labor force (% of population) in Hungary in 2002 to that in 2006?
Your answer should be very brief. 0.48. What is the ratio of the Unemployed and educated male labor force (% of population) in Latin America(developing only) in 2002 to that in 2007?
Give a very brief answer. 0.85. What is the ratio of the Unemployed and educated male labor force (% of population) in Australia in 2002 to that in 2007?
Make the answer very short. 0.97. What is the ratio of the Unemployed and educated male labor force (% of population) of Greece in 2002 to that in 2007?
Offer a very short reply. 0.62. What is the ratio of the Unemployed and educated male labor force (% of population) of Hungary in 2002 to that in 2007?
Offer a very short reply. 0.53. What is the ratio of the Unemployed and educated male labor force (% of population) in Latin America(developing only) in 2003 to that in 2004?
Make the answer very short. 0.83. What is the ratio of the Unemployed and educated male labor force (% of population) in Australia in 2003 to that in 2004?
Provide a succinct answer. 0.99. What is the ratio of the Unemployed and educated male labor force (% of population) of Greece in 2003 to that in 2004?
Offer a very short reply. 0.89. What is the ratio of the Unemployed and educated male labor force (% of population) of Hungary in 2003 to that in 2004?
Provide a succinct answer. 0.74. What is the ratio of the Unemployed and educated male labor force (% of population) of Latin America(developing only) in 2003 to that in 2005?
Give a very brief answer. 0.84. What is the ratio of the Unemployed and educated male labor force (% of population) in Australia in 2003 to that in 2005?
Provide a succinct answer. 0.98. What is the ratio of the Unemployed and educated male labor force (% of population) in Greece in 2003 to that in 2005?
Provide a succinct answer. 0.88. What is the ratio of the Unemployed and educated male labor force (% of population) of Hungary in 2003 to that in 2005?
Provide a succinct answer. 0.6. What is the ratio of the Unemployed and educated male labor force (% of population) of Latin America(developing only) in 2003 to that in 2006?
Your answer should be very brief. 1.01. What is the ratio of the Unemployed and educated male labor force (% of population) of Australia in 2003 to that in 2006?
Provide a succinct answer. 1.34. What is the ratio of the Unemployed and educated male labor force (% of population) in Greece in 2003 to that in 2006?
Offer a very short reply. 0.76. What is the ratio of the Unemployed and educated male labor force (% of population) of Hungary in 2003 to that in 2006?
Make the answer very short. 0.53. What is the ratio of the Unemployed and educated male labor force (% of population) in Latin America(developing only) in 2003 to that in 2007?
Keep it short and to the point. 0.81. What is the ratio of the Unemployed and educated male labor force (% of population) of Greece in 2003 to that in 2007?
Offer a terse response. 0.7. What is the ratio of the Unemployed and educated male labor force (% of population) of Hungary in 2003 to that in 2007?
Provide a short and direct response. 0.58. What is the ratio of the Unemployed and educated male labor force (% of population) of Latin America(developing only) in 2004 to that in 2005?
Ensure brevity in your answer.  1.01. What is the ratio of the Unemployed and educated male labor force (% of population) in Australia in 2004 to that in 2005?
Make the answer very short. 0.98. What is the ratio of the Unemployed and educated male labor force (% of population) in Greece in 2004 to that in 2005?
Make the answer very short. 0.99. What is the ratio of the Unemployed and educated male labor force (% of population) of Hungary in 2004 to that in 2005?
Ensure brevity in your answer.  0.81. What is the ratio of the Unemployed and educated male labor force (% of population) of Latin America(developing only) in 2004 to that in 2006?
Your answer should be very brief. 1.22. What is the ratio of the Unemployed and educated male labor force (% of population) of Australia in 2004 to that in 2006?
Your answer should be very brief. 1.34. What is the ratio of the Unemployed and educated male labor force (% of population) of Greece in 2004 to that in 2006?
Your answer should be very brief. 0.85. What is the ratio of the Unemployed and educated male labor force (% of population) of Hungary in 2004 to that in 2006?
Provide a succinct answer. 0.72. What is the ratio of the Unemployed and educated male labor force (% of population) of Latin America(developing only) in 2004 to that in 2007?
Make the answer very short. 0.98. What is the ratio of the Unemployed and educated male labor force (% of population) of Australia in 2004 to that in 2007?
Ensure brevity in your answer.  1.17. What is the ratio of the Unemployed and educated male labor force (% of population) of Greece in 2004 to that in 2007?
Give a very brief answer. 0.78. What is the ratio of the Unemployed and educated male labor force (% of population) in Hungary in 2004 to that in 2007?
Give a very brief answer. 0.78. What is the ratio of the Unemployed and educated male labor force (% of population) in Latin America(developing only) in 2005 to that in 2006?
Provide a short and direct response. 1.21. What is the ratio of the Unemployed and educated male labor force (% of population) of Australia in 2005 to that in 2006?
Provide a succinct answer. 1.37. What is the ratio of the Unemployed and educated male labor force (% of population) of Greece in 2005 to that in 2006?
Your response must be concise. 0.86. What is the ratio of the Unemployed and educated male labor force (% of population) of Hungary in 2005 to that in 2006?
Ensure brevity in your answer.  0.89. What is the ratio of the Unemployed and educated male labor force (% of population) of Latin America(developing only) in 2005 to that in 2007?
Ensure brevity in your answer.  0.97. What is the ratio of the Unemployed and educated male labor force (% of population) of Australia in 2005 to that in 2007?
Your answer should be compact. 1.19. What is the ratio of the Unemployed and educated male labor force (% of population) in Greece in 2005 to that in 2007?
Your answer should be compact. 0.79. What is the ratio of the Unemployed and educated male labor force (% of population) in Hungary in 2005 to that in 2007?
Provide a short and direct response. 0.97. What is the ratio of the Unemployed and educated male labor force (% of population) of Latin America(developing only) in 2006 to that in 2007?
Ensure brevity in your answer.  0.8. What is the ratio of the Unemployed and educated male labor force (% of population) in Australia in 2006 to that in 2007?
Offer a very short reply. 0.87. What is the ratio of the Unemployed and educated male labor force (% of population) of Greece in 2006 to that in 2007?
Provide a short and direct response. 0.92. What is the ratio of the Unemployed and educated male labor force (% of population) in Hungary in 2006 to that in 2007?
Provide a short and direct response. 1.08. What is the difference between the highest and the second highest Unemployed and educated male labor force (% of population) of Latin America(developing only)?
Keep it short and to the point. 0.25. What is the difference between the highest and the second highest Unemployed and educated male labor force (% of population) of Greece?
Provide a short and direct response. 1.5. What is the difference between the highest and the lowest Unemployed and educated male labor force (% of population) in Latin America(developing only)?
Provide a short and direct response. 2.75. What is the difference between the highest and the lowest Unemployed and educated male labor force (% of population) of Australia?
Offer a terse response. 5.2. What is the difference between the highest and the lowest Unemployed and educated male labor force (% of population) in Greece?
Keep it short and to the point. 7.4. What is the difference between the highest and the lowest Unemployed and educated male labor force (% of population) in Hungary?
Give a very brief answer. 3.9. 